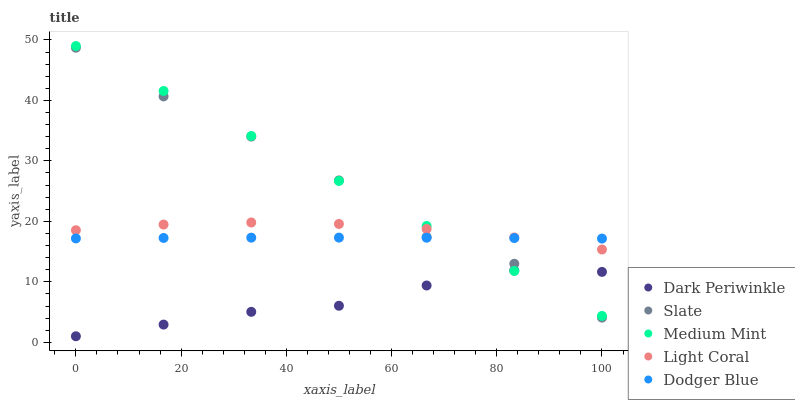Does Dark Periwinkle have the minimum area under the curve?
Answer yes or no. Yes. Does Medium Mint have the maximum area under the curve?
Answer yes or no. Yes. Does Light Coral have the minimum area under the curve?
Answer yes or no. No. Does Light Coral have the maximum area under the curve?
Answer yes or no. No. Is Medium Mint the smoothest?
Answer yes or no. Yes. Is Slate the roughest?
Answer yes or no. Yes. Is Light Coral the smoothest?
Answer yes or no. No. Is Light Coral the roughest?
Answer yes or no. No. Does Dark Periwinkle have the lowest value?
Answer yes or no. Yes. Does Light Coral have the lowest value?
Answer yes or no. No. Does Medium Mint have the highest value?
Answer yes or no. Yes. Does Light Coral have the highest value?
Answer yes or no. No. Is Dark Periwinkle less than Light Coral?
Answer yes or no. Yes. Is Light Coral greater than Dark Periwinkle?
Answer yes or no. Yes. Does Light Coral intersect Medium Mint?
Answer yes or no. Yes. Is Light Coral less than Medium Mint?
Answer yes or no. No. Is Light Coral greater than Medium Mint?
Answer yes or no. No. Does Dark Periwinkle intersect Light Coral?
Answer yes or no. No. 